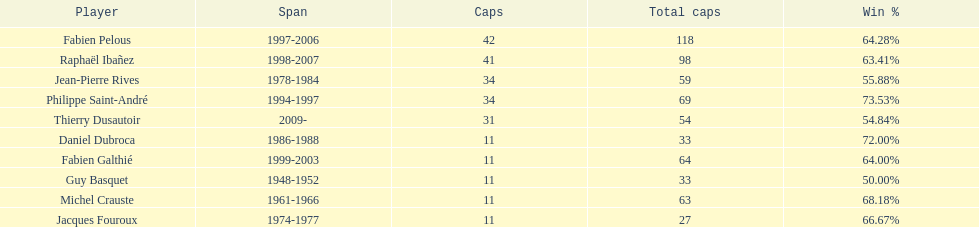Whose win percentage was the greatest? Philippe Saint-André. Could you help me parse every detail presented in this table? {'header': ['Player', 'Span', 'Caps', 'Total caps', 'Win\xa0%'], 'rows': [['Fabien Pelous', '1997-2006', '42', '118', '64.28%'], ['Raphaël Ibañez', '1998-2007', '41', '98', '63.41%'], ['Jean-Pierre Rives', '1978-1984', '34', '59', '55.88%'], ['Philippe Saint-André', '1994-1997', '34', '69', '73.53%'], ['Thierry Dusautoir', '2009-', '31', '54', '54.84%'], ['Daniel Dubroca', '1986-1988', '11', '33', '72.00%'], ['Fabien Galthié', '1999-2003', '11', '64', '64.00%'], ['Guy Basquet', '1948-1952', '11', '33', '50.00%'], ['Michel Crauste', '1961-1966', '11', '63', '68.18%'], ['Jacques Fouroux', '1974-1977', '11', '27', '66.67%']]} 